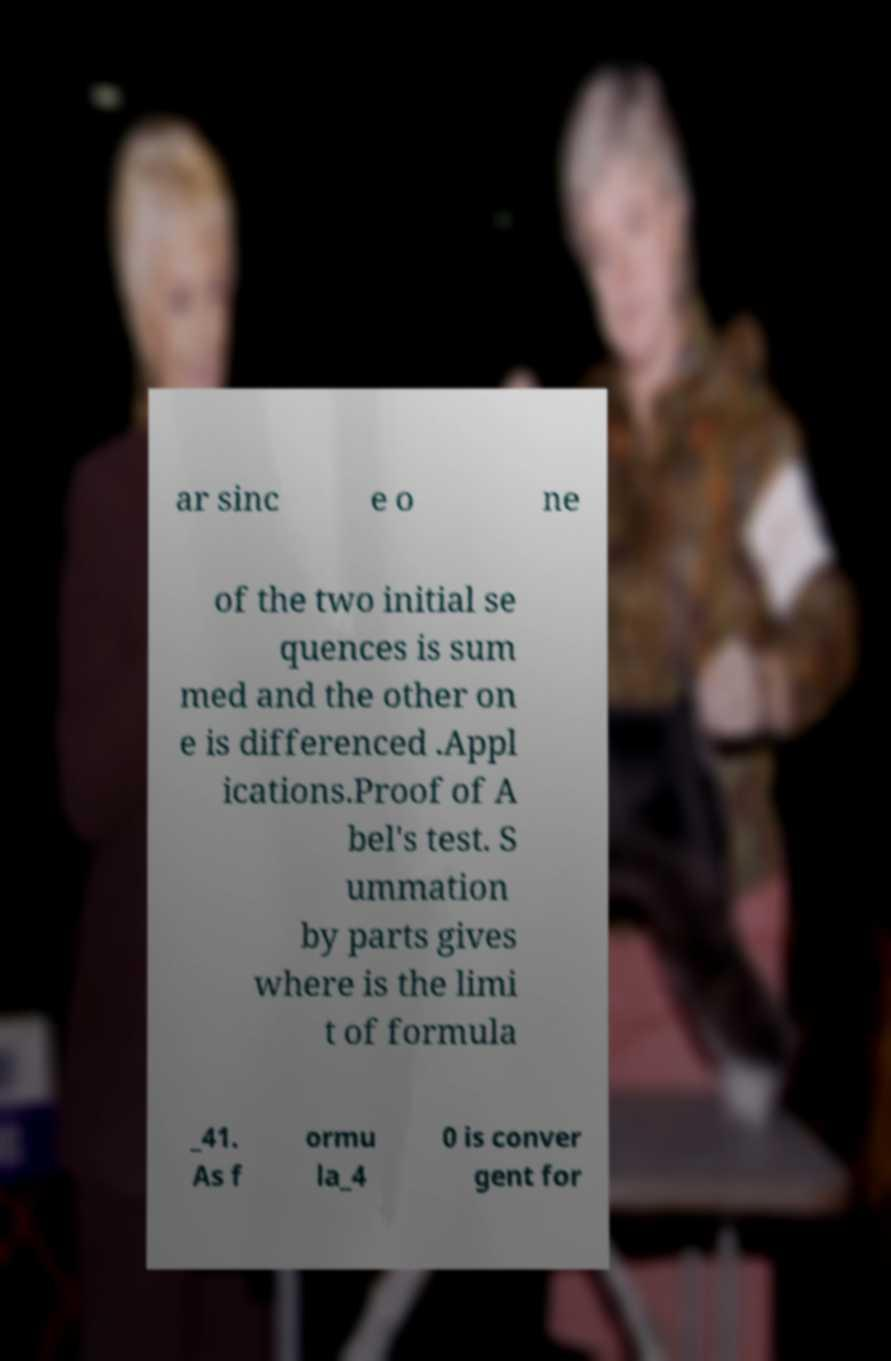Please identify and transcribe the text found in this image. ar sinc e o ne of the two initial se quences is sum med and the other on e is differenced .Appl ications.Proof of A bel's test. S ummation by parts gives where is the limi t of formula _41. As f ormu la_4 0 is conver gent for 